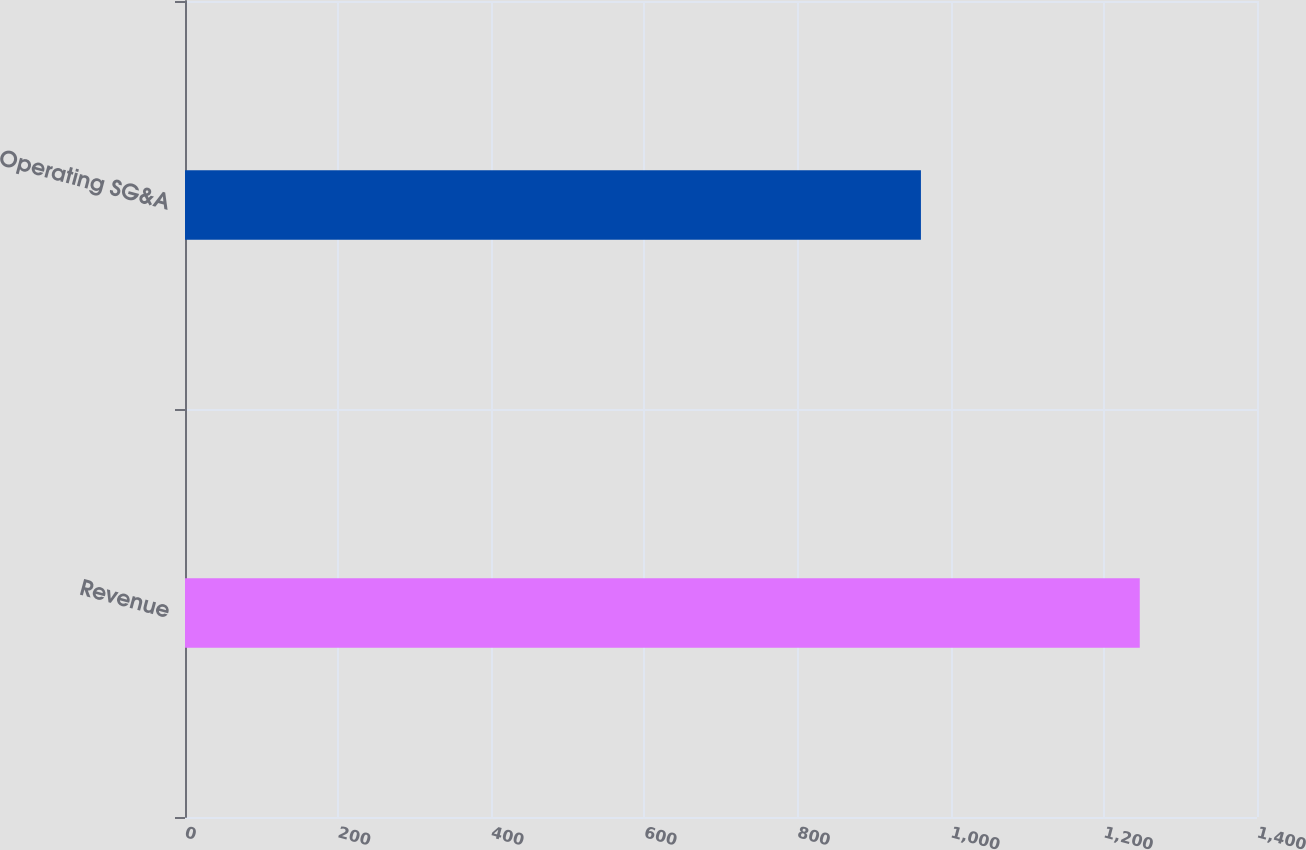Convert chart to OTSL. <chart><loc_0><loc_0><loc_500><loc_500><bar_chart><fcel>Revenue<fcel>Operating SG&A<nl><fcel>1246.9<fcel>961.1<nl></chart> 